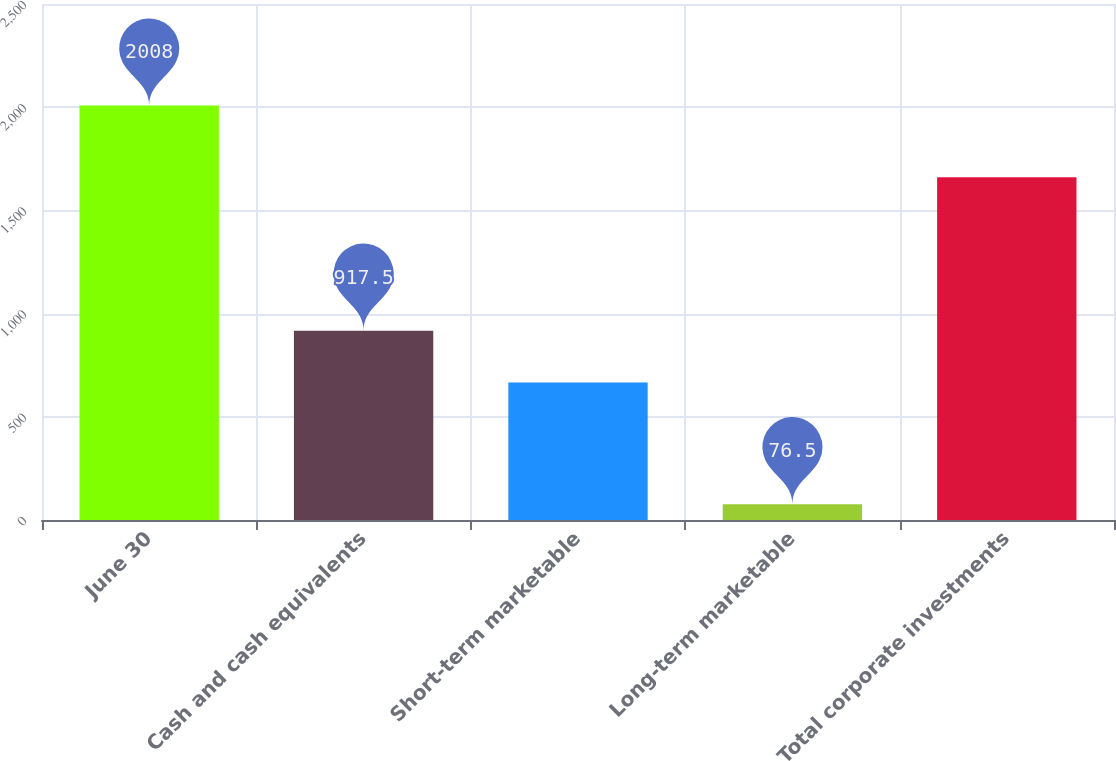Convert chart. <chart><loc_0><loc_0><loc_500><loc_500><bar_chart><fcel>June 30<fcel>Cash and cash equivalents<fcel>Short-term marketable<fcel>Long-term marketable<fcel>Total corporate investments<nl><fcel>2008<fcel>917.5<fcel>666.3<fcel>76.5<fcel>1660.3<nl></chart> 